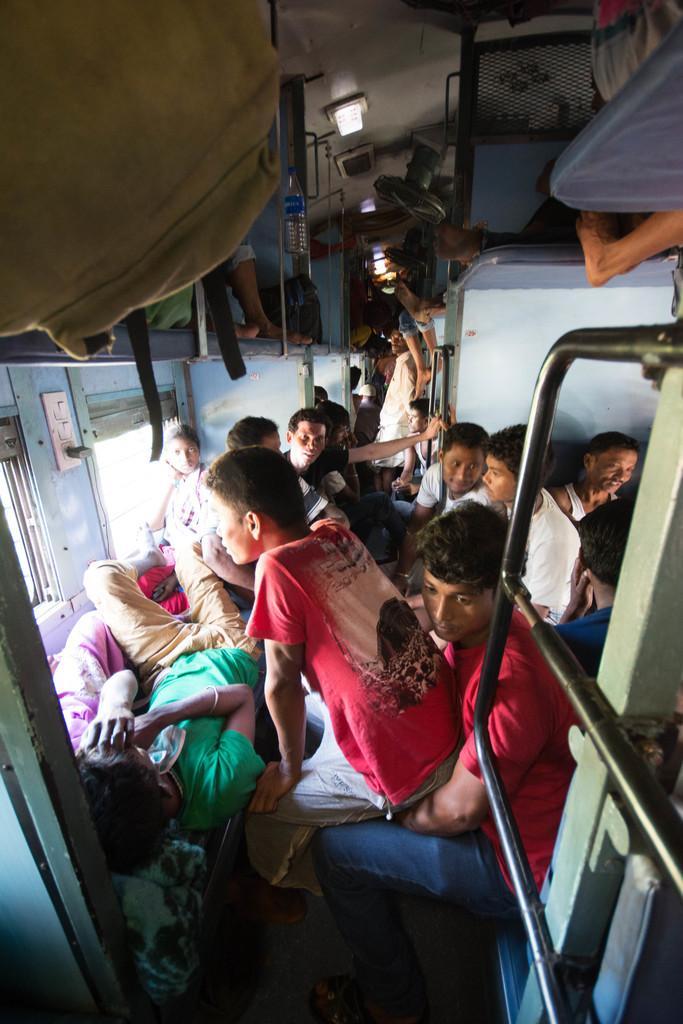In one or two sentences, can you explain what this image depicts? This is inside view of a rail, were we can see so many people are sitting on the seats and sleeping. At top left of the image some luggage is present. 